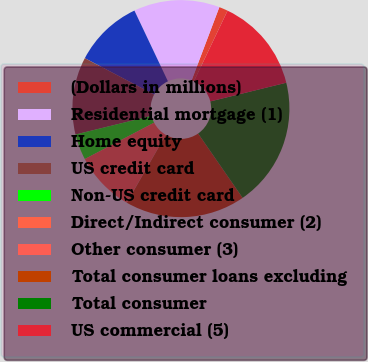Convert chart. <chart><loc_0><loc_0><loc_500><loc_500><pie_chart><fcel>(Dollars in millions)<fcel>Residential mortgage (1)<fcel>Home equity<fcel>US credit card<fcel>Non-US credit card<fcel>Direct/Indirect consumer (2)<fcel>Other consumer (3)<fcel>Total consumer loans excluding<fcel>Total consumer<fcel>US commercial (5)<nl><fcel>1.31%<fcel>12.81%<fcel>10.26%<fcel>11.53%<fcel>3.86%<fcel>8.98%<fcel>0.03%<fcel>17.93%<fcel>19.21%<fcel>14.09%<nl></chart> 